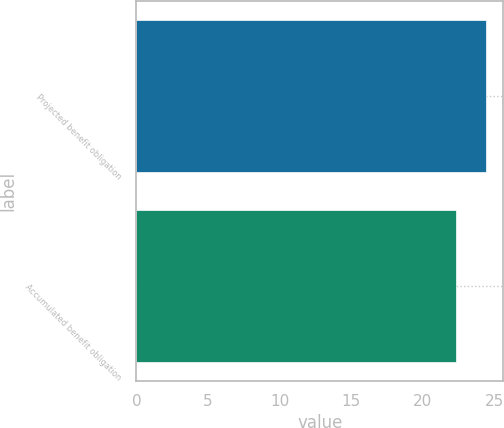Convert chart to OTSL. <chart><loc_0><loc_0><loc_500><loc_500><bar_chart><fcel>Projected benefit obligation<fcel>Accumulated benefit obligation<nl><fcel>24.4<fcel>22.3<nl></chart> 